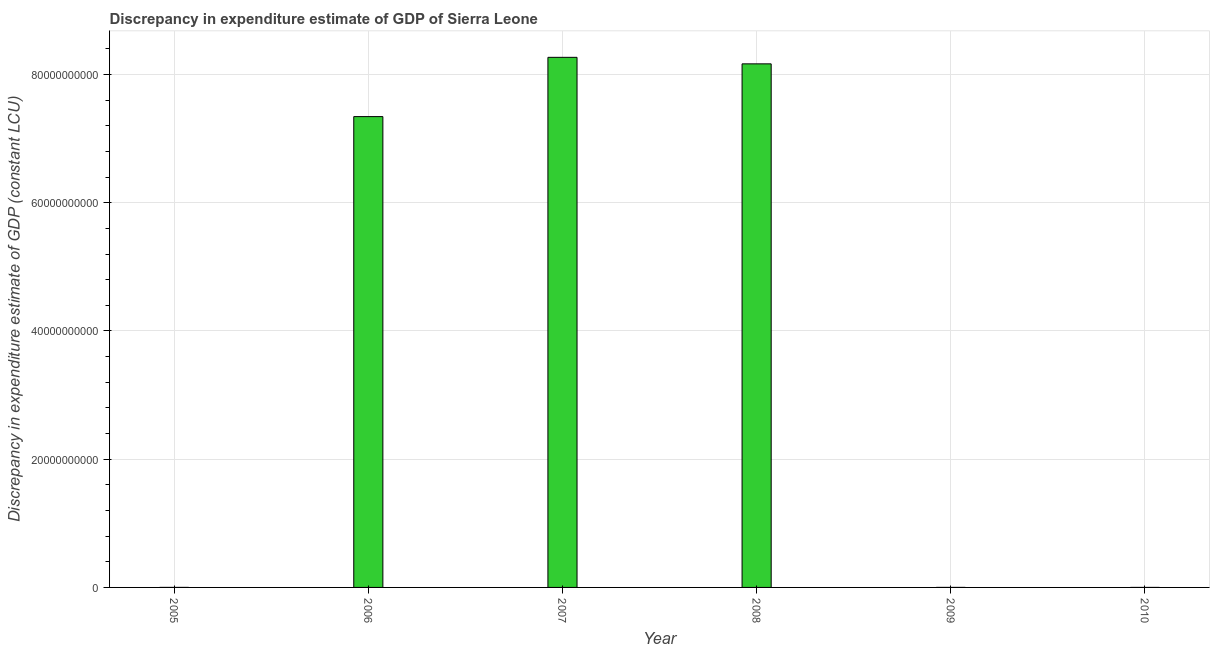Does the graph contain any zero values?
Your answer should be very brief. Yes. What is the title of the graph?
Your response must be concise. Discrepancy in expenditure estimate of GDP of Sierra Leone. What is the label or title of the X-axis?
Make the answer very short. Year. What is the label or title of the Y-axis?
Your response must be concise. Discrepancy in expenditure estimate of GDP (constant LCU). What is the discrepancy in expenditure estimate of gdp in 2009?
Keep it short and to the point. 7.69e+05. Across all years, what is the maximum discrepancy in expenditure estimate of gdp?
Keep it short and to the point. 8.27e+1. In which year was the discrepancy in expenditure estimate of gdp maximum?
Offer a terse response. 2007. What is the sum of the discrepancy in expenditure estimate of gdp?
Provide a succinct answer. 2.38e+11. What is the difference between the discrepancy in expenditure estimate of gdp in 2007 and 2008?
Your response must be concise. 1.02e+09. What is the average discrepancy in expenditure estimate of gdp per year?
Provide a short and direct response. 3.96e+1. What is the median discrepancy in expenditure estimate of gdp?
Give a very brief answer. 3.67e+1. What is the ratio of the discrepancy in expenditure estimate of gdp in 2008 to that in 2009?
Make the answer very short. 1.06e+05. Is the discrepancy in expenditure estimate of gdp in 2005 less than that in 2007?
Ensure brevity in your answer.  Yes. Is the difference between the discrepancy in expenditure estimate of gdp in 2005 and 2008 greater than the difference between any two years?
Your answer should be compact. No. What is the difference between the highest and the second highest discrepancy in expenditure estimate of gdp?
Provide a succinct answer. 1.02e+09. Is the sum of the discrepancy in expenditure estimate of gdp in 2008 and 2009 greater than the maximum discrepancy in expenditure estimate of gdp across all years?
Your answer should be compact. No. What is the difference between the highest and the lowest discrepancy in expenditure estimate of gdp?
Provide a short and direct response. 8.27e+1. In how many years, is the discrepancy in expenditure estimate of gdp greater than the average discrepancy in expenditure estimate of gdp taken over all years?
Provide a short and direct response. 3. How many bars are there?
Your response must be concise. 5. Are the values on the major ticks of Y-axis written in scientific E-notation?
Your response must be concise. No. What is the Discrepancy in expenditure estimate of GDP (constant LCU) in 2005?
Provide a succinct answer. 3.00e+06. What is the Discrepancy in expenditure estimate of GDP (constant LCU) of 2006?
Your answer should be very brief. 7.34e+1. What is the Discrepancy in expenditure estimate of GDP (constant LCU) in 2007?
Keep it short and to the point. 8.27e+1. What is the Discrepancy in expenditure estimate of GDP (constant LCU) in 2008?
Offer a very short reply. 8.17e+1. What is the Discrepancy in expenditure estimate of GDP (constant LCU) of 2009?
Make the answer very short. 7.69e+05. What is the difference between the Discrepancy in expenditure estimate of GDP (constant LCU) in 2005 and 2006?
Offer a very short reply. -7.34e+1. What is the difference between the Discrepancy in expenditure estimate of GDP (constant LCU) in 2005 and 2007?
Provide a succinct answer. -8.27e+1. What is the difference between the Discrepancy in expenditure estimate of GDP (constant LCU) in 2005 and 2008?
Your response must be concise. -8.17e+1. What is the difference between the Discrepancy in expenditure estimate of GDP (constant LCU) in 2005 and 2009?
Offer a very short reply. 2.23e+06. What is the difference between the Discrepancy in expenditure estimate of GDP (constant LCU) in 2006 and 2007?
Offer a terse response. -9.24e+09. What is the difference between the Discrepancy in expenditure estimate of GDP (constant LCU) in 2006 and 2008?
Your answer should be compact. -8.23e+09. What is the difference between the Discrepancy in expenditure estimate of GDP (constant LCU) in 2006 and 2009?
Keep it short and to the point. 7.34e+1. What is the difference between the Discrepancy in expenditure estimate of GDP (constant LCU) in 2007 and 2008?
Your answer should be very brief. 1.02e+09. What is the difference between the Discrepancy in expenditure estimate of GDP (constant LCU) in 2007 and 2009?
Keep it short and to the point. 8.27e+1. What is the difference between the Discrepancy in expenditure estimate of GDP (constant LCU) in 2008 and 2009?
Keep it short and to the point. 8.17e+1. What is the ratio of the Discrepancy in expenditure estimate of GDP (constant LCU) in 2005 to that in 2007?
Provide a succinct answer. 0. What is the ratio of the Discrepancy in expenditure estimate of GDP (constant LCU) in 2005 to that in 2009?
Give a very brief answer. 3.9. What is the ratio of the Discrepancy in expenditure estimate of GDP (constant LCU) in 2006 to that in 2007?
Provide a short and direct response. 0.89. What is the ratio of the Discrepancy in expenditure estimate of GDP (constant LCU) in 2006 to that in 2008?
Ensure brevity in your answer.  0.9. What is the ratio of the Discrepancy in expenditure estimate of GDP (constant LCU) in 2006 to that in 2009?
Ensure brevity in your answer.  9.55e+04. What is the ratio of the Discrepancy in expenditure estimate of GDP (constant LCU) in 2007 to that in 2009?
Give a very brief answer. 1.08e+05. What is the ratio of the Discrepancy in expenditure estimate of GDP (constant LCU) in 2008 to that in 2009?
Provide a succinct answer. 1.06e+05. 